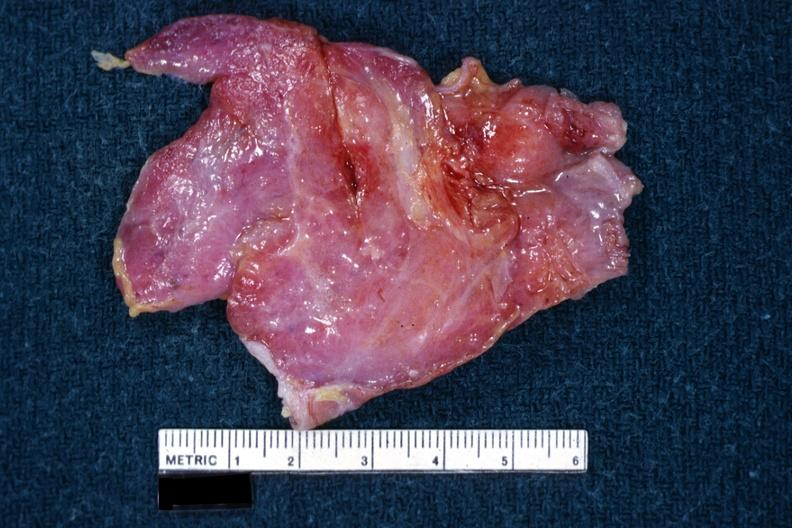s thymus present?
Answer the question using a single word or phrase. Yes 